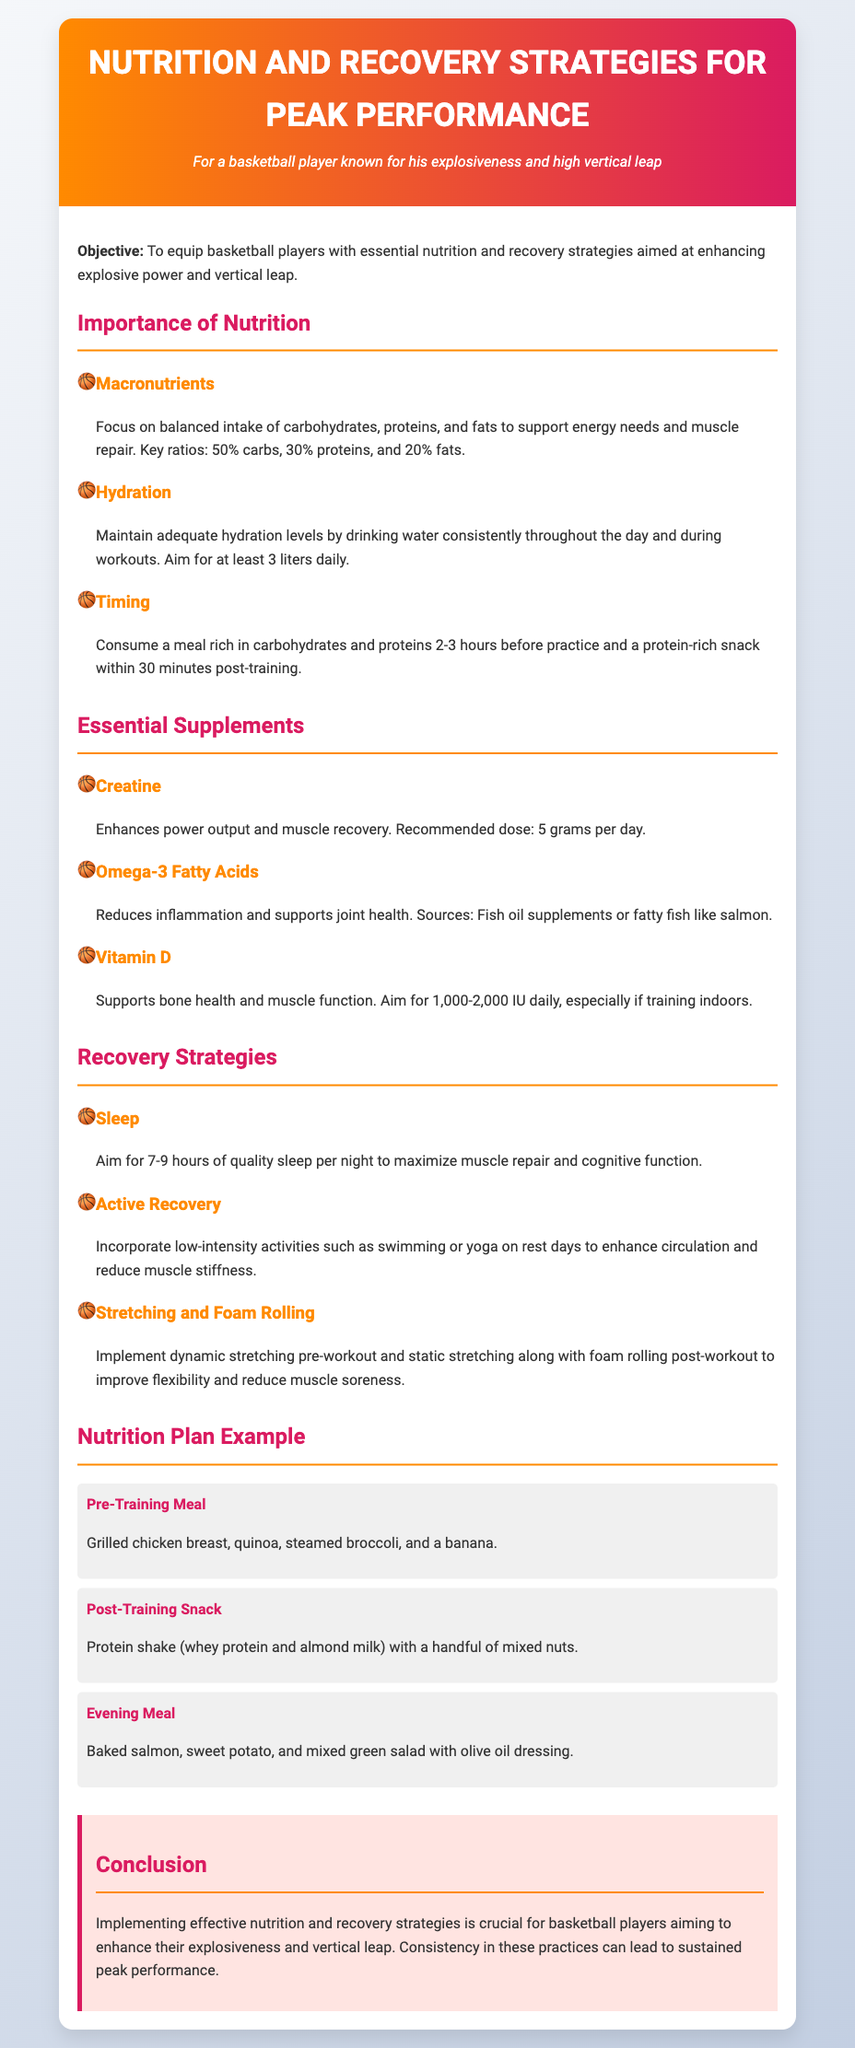What are the key macronutrient ratios? The document outlines the recommended ratios for macronutrients important for nutrition: 50% carbs, 30% proteins, and 20% fats.
Answer: 50% carbs, 30% proteins, 20% fats What is the recommended daily water intake? The document states the daily hydration goal for players, which is at least 3 liters.
Answer: 3 liters What supplement enhances power output? The lesson plan mentions creatine as a supplement that enhances power output and muscle recovery.
Answer: Creatine How many hours of sleep should athletes aim for? The document advises athletes to aim for 7-9 hours of quality sleep per night for muscle repair and cognitive function.
Answer: 7-9 hours What is included in the pre-training meal? The document provides an example pre-training meal which consists of grilled chicken breast, quinoa, steamed broccoli, and a banana.
Answer: Grilled chicken breast, quinoa, steamed broccoli, and a banana What recovery strategy involves low-intensity activities? The document refers to active recovery as incorporating low-intensity activities such as swimming or yoga on rest days.
Answer: Active Recovery What is the purpose of omega-3 fatty acids? The document explains that omega-3 fatty acids reduce inflammation and support joint health.
Answer: Reduce inflammation and support joint health What type of stretching is recommended post-workout? The lesson plan recommends static stretching along with foam rolling as a key post-workout activity.
Answer: Static stretching and foam rolling 